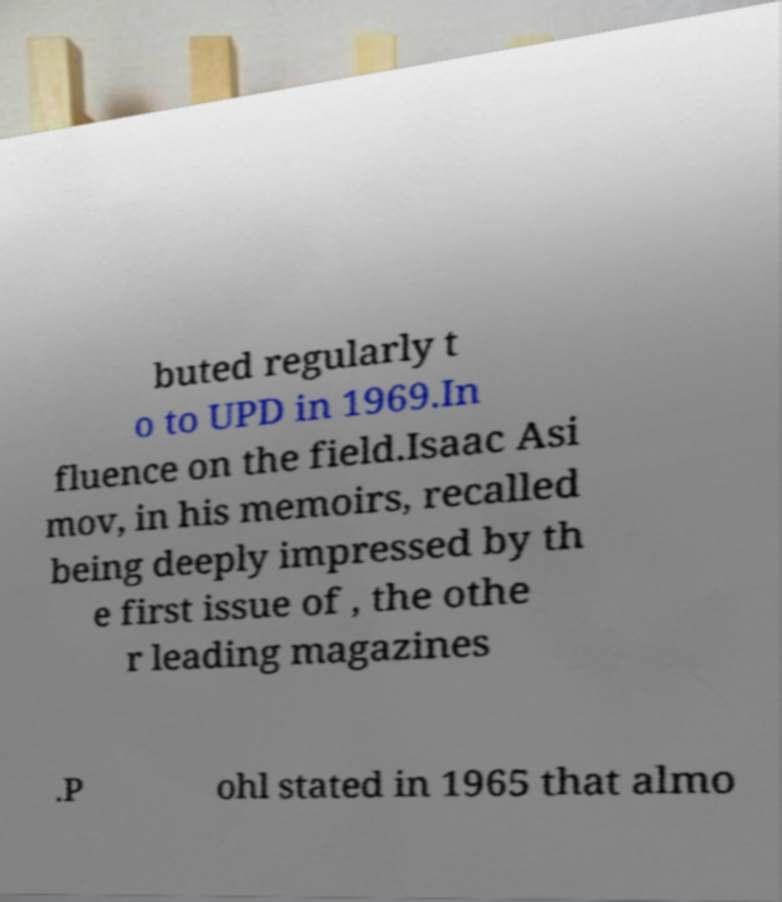Could you assist in decoding the text presented in this image and type it out clearly? buted regularly t o to UPD in 1969.In fluence on the field.Isaac Asi mov, in his memoirs, recalled being deeply impressed by th e first issue of , the othe r leading magazines .P ohl stated in 1965 that almo 